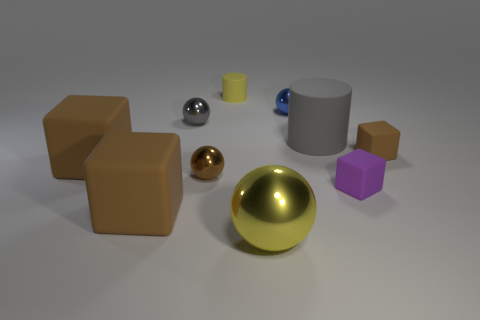Subtract all big spheres. How many spheres are left? 3 Subtract all purple cubes. How many cubes are left? 3 Subtract all blocks. How many objects are left? 6 Subtract all red balls. How many brown blocks are left? 3 Add 2 small purple matte things. How many small purple matte things are left? 3 Add 1 small red shiny cylinders. How many small red shiny cylinders exist? 1 Subtract 0 brown cylinders. How many objects are left? 10 Subtract 3 spheres. How many spheres are left? 1 Subtract all yellow cylinders. Subtract all gray spheres. How many cylinders are left? 1 Subtract all red shiny cylinders. Subtract all big blocks. How many objects are left? 8 